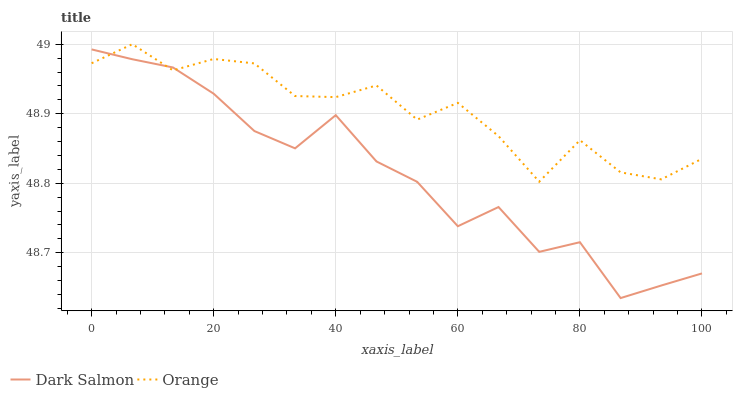Does Dark Salmon have the minimum area under the curve?
Answer yes or no. Yes. Does Orange have the maximum area under the curve?
Answer yes or no. Yes. Does Dark Salmon have the maximum area under the curve?
Answer yes or no. No. Is Orange the smoothest?
Answer yes or no. Yes. Is Dark Salmon the roughest?
Answer yes or no. Yes. Is Dark Salmon the smoothest?
Answer yes or no. No. Does Dark Salmon have the lowest value?
Answer yes or no. Yes. Does Orange have the highest value?
Answer yes or no. Yes. Does Dark Salmon have the highest value?
Answer yes or no. No. Does Orange intersect Dark Salmon?
Answer yes or no. Yes. Is Orange less than Dark Salmon?
Answer yes or no. No. Is Orange greater than Dark Salmon?
Answer yes or no. No. 